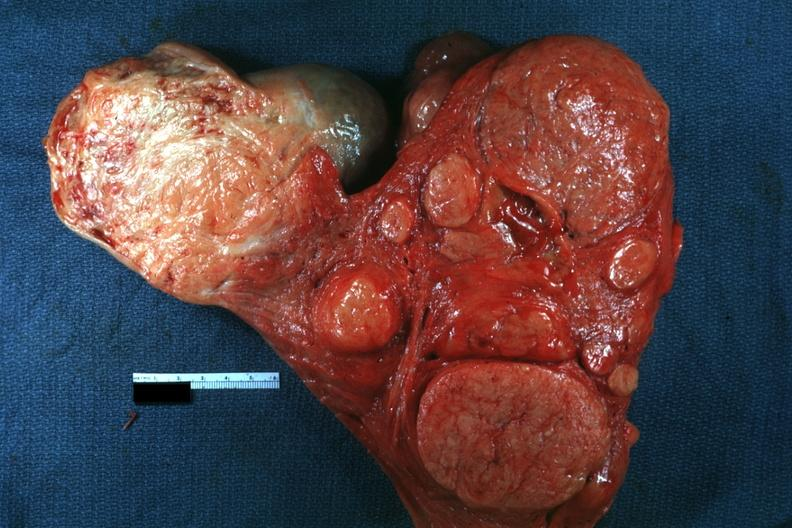does this image show multiple typical lesions good depiction?
Answer the question using a single word or phrase. Yes 